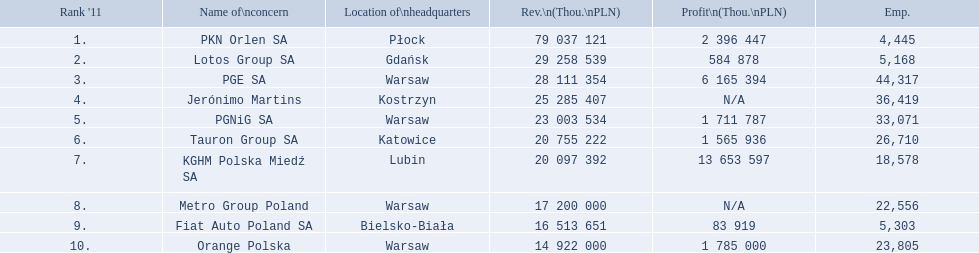Which concern's headquarters are located in warsaw? PGE SA, PGNiG SA, Metro Group Poland. Which of these listed a profit? PGE SA, PGNiG SA. Of these how many employees are in the concern with the lowest profit? 33,071. 